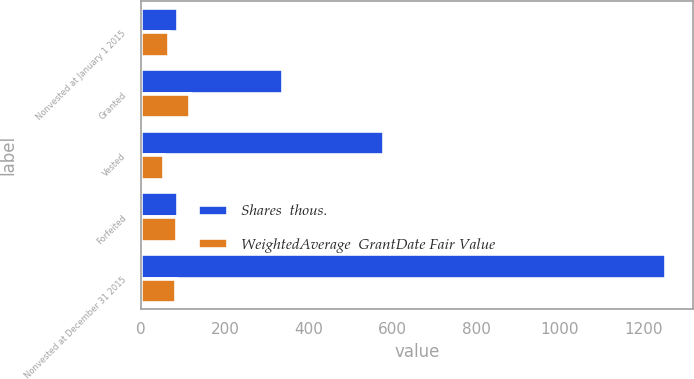Convert chart to OTSL. <chart><loc_0><loc_0><loc_500><loc_500><stacked_bar_chart><ecel><fcel>Nonvested at January 1 2015<fcel>Granted<fcel>Vested<fcel>Forfeited<fcel>Nonvested at December 31 2015<nl><fcel>Shares  thous.<fcel>87<fcel>339<fcel>580<fcel>87<fcel>1255<nl><fcel>WeightedAverage  GrantDate Fair Value<fcel>65.33<fcel>117.42<fcel>54.38<fcel>86.66<fcel>82.98<nl></chart> 